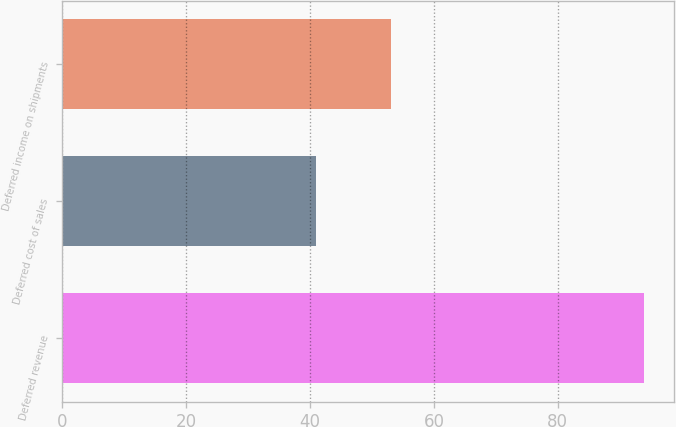<chart> <loc_0><loc_0><loc_500><loc_500><bar_chart><fcel>Deferred revenue<fcel>Deferred cost of sales<fcel>Deferred income on shipments<nl><fcel>94<fcel>41<fcel>53<nl></chart> 